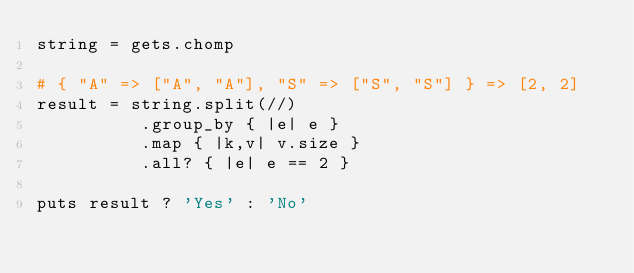<code> <loc_0><loc_0><loc_500><loc_500><_Ruby_>string = gets.chomp

# { "A" => ["A", "A"], "S" => ["S", "S"] } => [2, 2]
result = string.split(//)
          .group_by { |e| e }
          .map { |k,v| v.size }
          .all? { |e| e == 2 }

puts result ? 'Yes' : 'No'</code> 